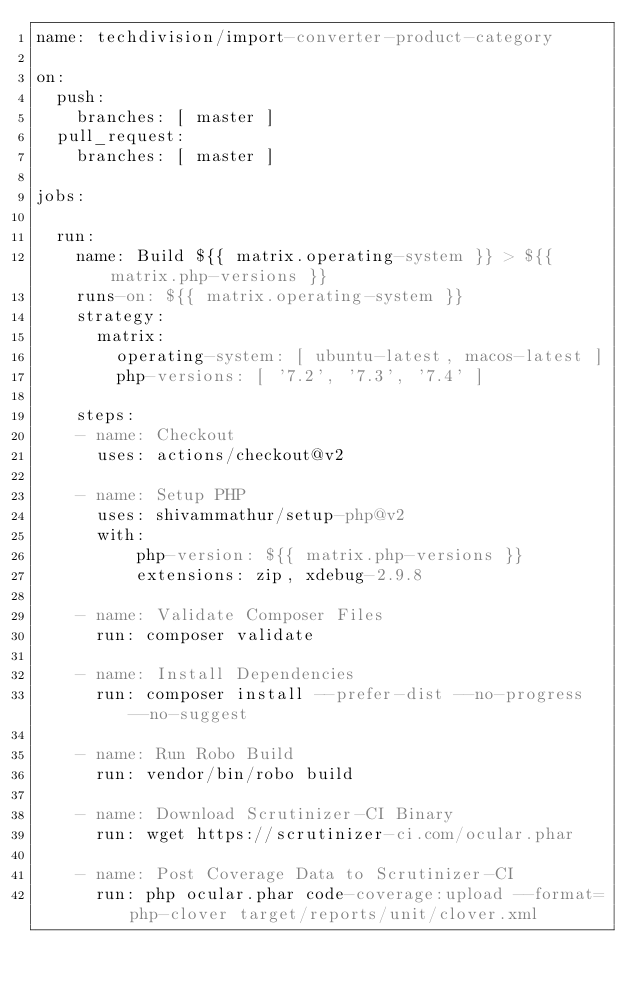<code> <loc_0><loc_0><loc_500><loc_500><_YAML_>name: techdivision/import-converter-product-category

on:
  push:
    branches: [ master ]
  pull_request:
    branches: [ master ]

jobs:
    
  run:
    name: Build ${{ matrix.operating-system }} > ${{ matrix.php-versions }}
    runs-on: ${{ matrix.operating-system }}
    strategy:
      matrix:
        operating-system: [ ubuntu-latest, macos-latest ]
        php-versions: [ '7.2', '7.3', '7.4' ]

    steps:
    - name: Checkout
      uses: actions/checkout@v2
      
    - name: Setup PHP
      uses: shivammathur/setup-php@v2
      with:
          php-version: ${{ matrix.php-versions }}
          extensions: zip, xdebug-2.9.8 

    - name: Validate Composer Files
      run: composer validate

    - name: Install Dependencies
      run: composer install --prefer-dist --no-progress --no-suggest

    - name: Run Robo Build
      run: vendor/bin/robo build
      
    - name: Download Scrutinizer-CI Binary
      run: wget https://scrutinizer-ci.com/ocular.phar
    
    - name: Post Coverage Data to Scrutinizer-CI
      run: php ocular.phar code-coverage:upload --format=php-clover target/reports/unit/clover.xml
</code> 